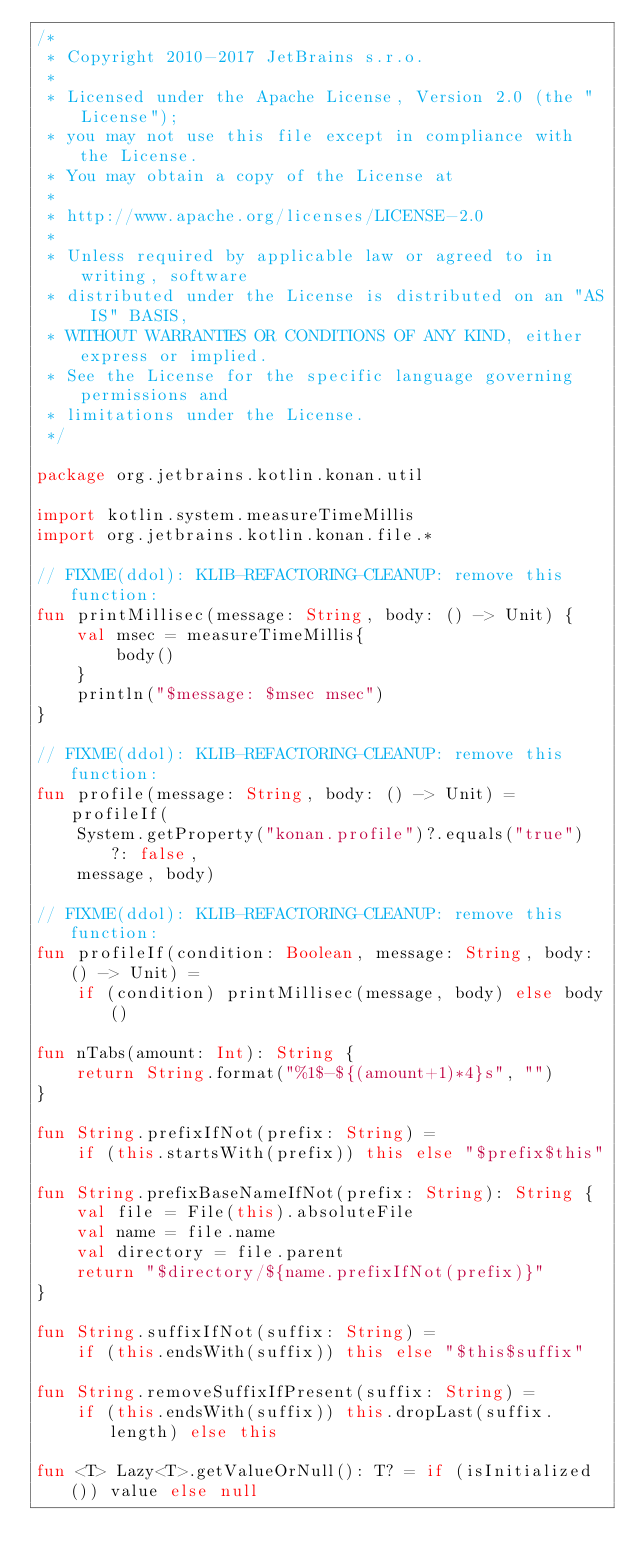Convert code to text. <code><loc_0><loc_0><loc_500><loc_500><_Kotlin_>/*
 * Copyright 2010-2017 JetBrains s.r.o.
 *
 * Licensed under the Apache License, Version 2.0 (the "License");
 * you may not use this file except in compliance with the License.
 * You may obtain a copy of the License at
 *
 * http://www.apache.org/licenses/LICENSE-2.0
 *
 * Unless required by applicable law or agreed to in writing, software
 * distributed under the License is distributed on an "AS IS" BASIS,
 * WITHOUT WARRANTIES OR CONDITIONS OF ANY KIND, either express or implied.
 * See the License for the specific language governing permissions and
 * limitations under the License.
 */

package org.jetbrains.kotlin.konan.util

import kotlin.system.measureTimeMillis
import org.jetbrains.kotlin.konan.file.*

// FIXME(ddol): KLIB-REFACTORING-CLEANUP: remove this function:
fun printMillisec(message: String, body: () -> Unit) {
    val msec = measureTimeMillis{
        body()
    }
    println("$message: $msec msec")
}

// FIXME(ddol): KLIB-REFACTORING-CLEANUP: remove this function:
fun profile(message: String, body: () -> Unit) = profileIf(
    System.getProperty("konan.profile")?.equals("true") ?: false,
    message, body)

// FIXME(ddol): KLIB-REFACTORING-CLEANUP: remove this function:
fun profileIf(condition: Boolean, message: String, body: () -> Unit) =
    if (condition) printMillisec(message, body) else body()

fun nTabs(amount: Int): String {
    return String.format("%1$-${(amount+1)*4}s", "") 
}

fun String.prefixIfNot(prefix: String) =
    if (this.startsWith(prefix)) this else "$prefix$this"

fun String.prefixBaseNameIfNot(prefix: String): String {
    val file = File(this).absoluteFile
    val name = file.name
    val directory = file.parent
    return "$directory/${name.prefixIfNot(prefix)}"
}

fun String.suffixIfNot(suffix: String) =
    if (this.endsWith(suffix)) this else "$this$suffix"

fun String.removeSuffixIfPresent(suffix: String) =
    if (this.endsWith(suffix)) this.dropLast(suffix.length) else this

fun <T> Lazy<T>.getValueOrNull(): T? = if (isInitialized()) value else null
</code> 